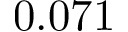Convert formula to latex. <formula><loc_0><loc_0><loc_500><loc_500>0 . 0 7 1</formula> 